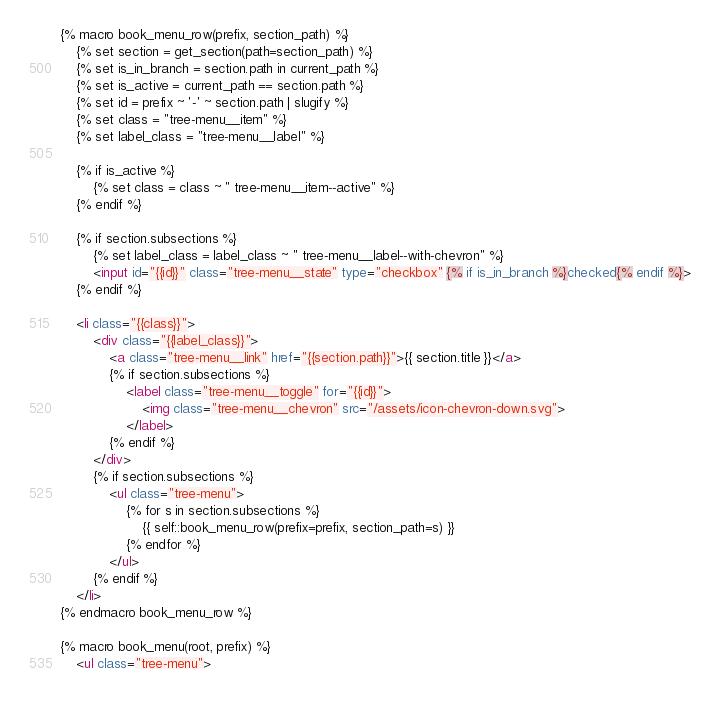Convert code to text. <code><loc_0><loc_0><loc_500><loc_500><_HTML_>{% macro book_menu_row(prefix, section_path) %}
    {% set section = get_section(path=section_path) %}
    {% set is_in_branch = section.path in current_path %}
    {% set is_active = current_path == section.path %}
    {% set id = prefix ~ '-' ~ section.path | slugify %}
    {% set class = "tree-menu__item" %}
    {% set label_class = "tree-menu__label" %}

    {% if is_active %}
        {% set class = class ~ " tree-menu__item--active" %}
    {% endif %}

    {% if section.subsections %}
        {% set label_class = label_class ~ " tree-menu__label--with-chevron" %}
        <input id="{{id}}" class="tree-menu__state" type="checkbox" {% if is_in_branch %}checked{% endif %}>
    {% endif %}

    <li class="{{class}}">
        <div class="{{label_class}}">
            <a class="tree-menu__link" href="{{section.path}}">{{ section.title }}</a>
            {% if section.subsections %}
                <label class="tree-menu__toggle" for="{{id}}">
                    <img class="tree-menu__chevron" src="/assets/icon-chevron-down.svg">
                </label>
            {% endif %}
        </div>
        {% if section.subsections %}
            <ul class="tree-menu">
                {% for s in section.subsections %}
                    {{ self::book_menu_row(prefix=prefix, section_path=s) }}
                {% endfor %}
            </ul>
        {% endif %}
    </li>
{% endmacro book_menu_row %}

{% macro book_menu(root, prefix) %}
    <ul class="tree-menu"></code> 